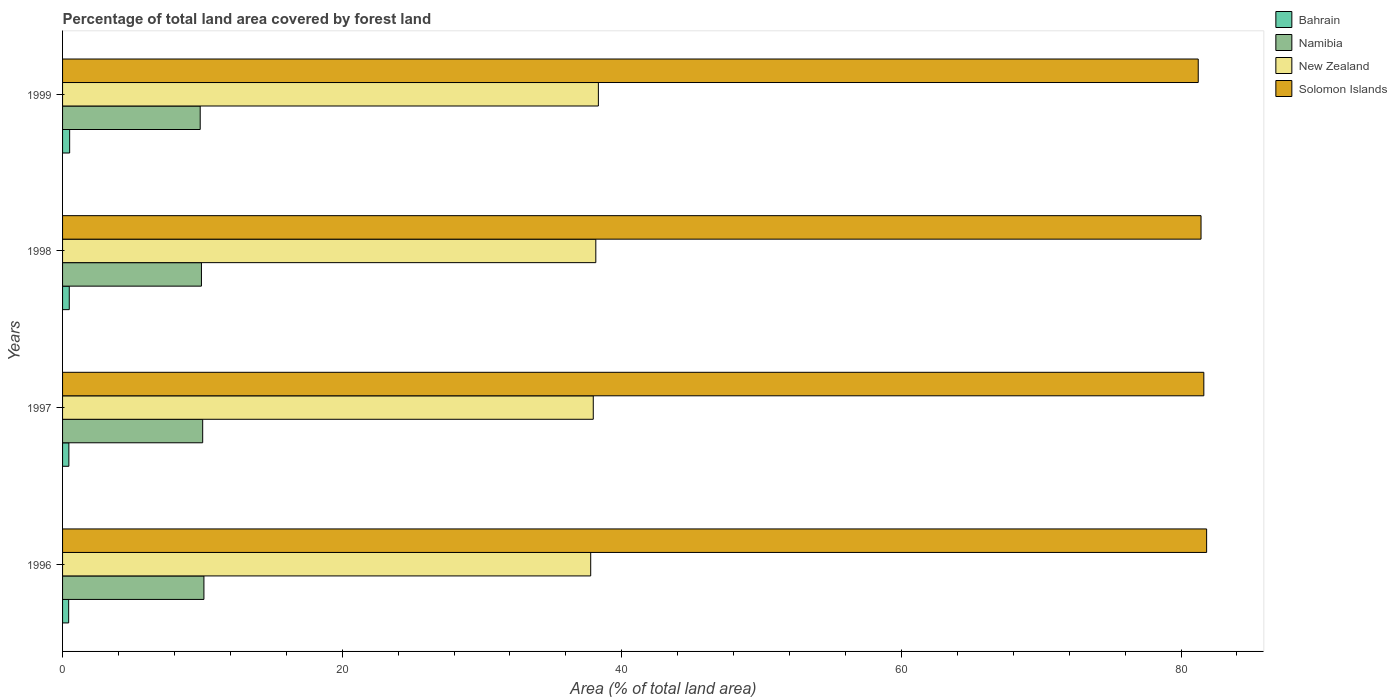How many different coloured bars are there?
Keep it short and to the point. 4. How many groups of bars are there?
Keep it short and to the point. 4. How many bars are there on the 3rd tick from the bottom?
Make the answer very short. 4. What is the label of the 1st group of bars from the top?
Keep it short and to the point. 1999. What is the percentage of forest land in Bahrain in 1997?
Provide a short and direct response. 0.45. Across all years, what is the maximum percentage of forest land in Solomon Islands?
Keep it short and to the point. 81.83. Across all years, what is the minimum percentage of forest land in Bahrain?
Give a very brief answer. 0.44. In which year was the percentage of forest land in Bahrain maximum?
Offer a terse response. 1999. What is the total percentage of forest land in New Zealand in the graph?
Your response must be concise. 152.2. What is the difference between the percentage of forest land in Solomon Islands in 1998 and that in 1999?
Your response must be concise. 0.2. What is the difference between the percentage of forest land in New Zealand in 1997 and the percentage of forest land in Namibia in 1999?
Make the answer very short. 28.11. What is the average percentage of forest land in New Zealand per year?
Make the answer very short. 38.05. In the year 1997, what is the difference between the percentage of forest land in New Zealand and percentage of forest land in Namibia?
Provide a short and direct response. 27.94. In how many years, is the percentage of forest land in Bahrain greater than 4 %?
Ensure brevity in your answer.  0. What is the ratio of the percentage of forest land in Solomon Islands in 1998 to that in 1999?
Make the answer very short. 1. Is the percentage of forest land in Bahrain in 1996 less than that in 1997?
Ensure brevity in your answer.  Yes. Is the difference between the percentage of forest land in New Zealand in 1996 and 1998 greater than the difference between the percentage of forest land in Namibia in 1996 and 1998?
Offer a very short reply. No. What is the difference between the highest and the second highest percentage of forest land in New Zealand?
Your answer should be compact. 0.18. What is the difference between the highest and the lowest percentage of forest land in Bahrain?
Provide a short and direct response. 0.07. Is the sum of the percentage of forest land in Solomon Islands in 1996 and 1997 greater than the maximum percentage of forest land in New Zealand across all years?
Provide a short and direct response. Yes. Is it the case that in every year, the sum of the percentage of forest land in Solomon Islands and percentage of forest land in Namibia is greater than the sum of percentage of forest land in Bahrain and percentage of forest land in New Zealand?
Make the answer very short. Yes. What does the 1st bar from the top in 1997 represents?
Your answer should be very brief. Solomon Islands. What does the 4th bar from the bottom in 1997 represents?
Offer a terse response. Solomon Islands. Is it the case that in every year, the sum of the percentage of forest land in New Zealand and percentage of forest land in Namibia is greater than the percentage of forest land in Bahrain?
Ensure brevity in your answer.  Yes. How many years are there in the graph?
Make the answer very short. 4. How are the legend labels stacked?
Offer a very short reply. Vertical. What is the title of the graph?
Offer a terse response. Percentage of total land area covered by forest land. What is the label or title of the X-axis?
Provide a short and direct response. Area (% of total land area). What is the label or title of the Y-axis?
Your response must be concise. Years. What is the Area (% of total land area) in Bahrain in 1996?
Your answer should be very brief. 0.44. What is the Area (% of total land area) in Namibia in 1996?
Offer a very short reply. 10.11. What is the Area (% of total land area) in New Zealand in 1996?
Provide a succinct answer. 37.78. What is the Area (% of total land area) of Solomon Islands in 1996?
Your answer should be compact. 81.83. What is the Area (% of total land area) of Bahrain in 1997?
Your response must be concise. 0.45. What is the Area (% of total land area) in Namibia in 1997?
Provide a short and direct response. 10.02. What is the Area (% of total land area) of New Zealand in 1997?
Make the answer very short. 37.96. What is the Area (% of total land area) of Solomon Islands in 1997?
Keep it short and to the point. 81.63. What is the Area (% of total land area) in Bahrain in 1998?
Your answer should be compact. 0.48. What is the Area (% of total land area) of Namibia in 1998?
Ensure brevity in your answer.  9.93. What is the Area (% of total land area) in New Zealand in 1998?
Your answer should be compact. 38.14. What is the Area (% of total land area) in Solomon Islands in 1998?
Provide a short and direct response. 81.43. What is the Area (% of total land area) of Bahrain in 1999?
Your answer should be compact. 0.51. What is the Area (% of total land area) in Namibia in 1999?
Your answer should be compact. 9.84. What is the Area (% of total land area) of New Zealand in 1999?
Keep it short and to the point. 38.32. What is the Area (% of total land area) in Solomon Islands in 1999?
Offer a very short reply. 81.23. Across all years, what is the maximum Area (% of total land area) in Bahrain?
Your response must be concise. 0.51. Across all years, what is the maximum Area (% of total land area) of Namibia?
Provide a short and direct response. 10.11. Across all years, what is the maximum Area (% of total land area) of New Zealand?
Provide a short and direct response. 38.32. Across all years, what is the maximum Area (% of total land area) of Solomon Islands?
Make the answer very short. 81.83. Across all years, what is the minimum Area (% of total land area) in Bahrain?
Your answer should be compact. 0.44. Across all years, what is the minimum Area (% of total land area) in Namibia?
Give a very brief answer. 9.84. Across all years, what is the minimum Area (% of total land area) in New Zealand?
Provide a succinct answer. 37.78. Across all years, what is the minimum Area (% of total land area) of Solomon Islands?
Your answer should be very brief. 81.23. What is the total Area (% of total land area) in Bahrain in the graph?
Your answer should be very brief. 1.87. What is the total Area (% of total land area) of Namibia in the graph?
Offer a very short reply. 39.91. What is the total Area (% of total land area) of New Zealand in the graph?
Provide a short and direct response. 152.2. What is the total Area (% of total land area) in Solomon Islands in the graph?
Give a very brief answer. 326.12. What is the difference between the Area (% of total land area) in Bahrain in 1996 and that in 1997?
Provide a short and direct response. -0.01. What is the difference between the Area (% of total land area) of Namibia in 1996 and that in 1997?
Offer a very short reply. 0.09. What is the difference between the Area (% of total land area) in New Zealand in 1996 and that in 1997?
Give a very brief answer. -0.18. What is the difference between the Area (% of total land area) in Solomon Islands in 1996 and that in 1997?
Offer a terse response. 0.2. What is the difference between the Area (% of total land area) of Bahrain in 1996 and that in 1998?
Your answer should be very brief. -0.04. What is the difference between the Area (% of total land area) in Namibia in 1996 and that in 1998?
Offer a very short reply. 0.18. What is the difference between the Area (% of total land area) of New Zealand in 1996 and that in 1998?
Keep it short and to the point. -0.37. What is the difference between the Area (% of total land area) in Solomon Islands in 1996 and that in 1998?
Provide a short and direct response. 0.4. What is the difference between the Area (% of total land area) of Bahrain in 1996 and that in 1999?
Provide a short and direct response. -0.07. What is the difference between the Area (% of total land area) in Namibia in 1996 and that in 1999?
Your answer should be very brief. 0.27. What is the difference between the Area (% of total land area) in New Zealand in 1996 and that in 1999?
Give a very brief answer. -0.55. What is the difference between the Area (% of total land area) in Solomon Islands in 1996 and that in 1999?
Ensure brevity in your answer.  0.6. What is the difference between the Area (% of total land area) of Bahrain in 1997 and that in 1998?
Offer a terse response. -0.03. What is the difference between the Area (% of total land area) in Namibia in 1997 and that in 1998?
Your response must be concise. 0.09. What is the difference between the Area (% of total land area) in New Zealand in 1997 and that in 1998?
Offer a terse response. -0.18. What is the difference between the Area (% of total land area) in Solomon Islands in 1997 and that in 1998?
Ensure brevity in your answer.  0.2. What is the difference between the Area (% of total land area) in Bahrain in 1997 and that in 1999?
Keep it short and to the point. -0.06. What is the difference between the Area (% of total land area) in Namibia in 1997 and that in 1999?
Your response must be concise. 0.18. What is the difference between the Area (% of total land area) in New Zealand in 1997 and that in 1999?
Provide a short and direct response. -0.37. What is the difference between the Area (% of total land area) in Solomon Islands in 1997 and that in 1999?
Offer a very short reply. 0.4. What is the difference between the Area (% of total land area) in Bahrain in 1998 and that in 1999?
Offer a terse response. -0.03. What is the difference between the Area (% of total land area) in Namibia in 1998 and that in 1999?
Your answer should be very brief. 0.09. What is the difference between the Area (% of total land area) of New Zealand in 1998 and that in 1999?
Ensure brevity in your answer.  -0.18. What is the difference between the Area (% of total land area) of Solomon Islands in 1998 and that in 1999?
Provide a short and direct response. 0.2. What is the difference between the Area (% of total land area) of Bahrain in 1996 and the Area (% of total land area) of Namibia in 1997?
Provide a short and direct response. -9.59. What is the difference between the Area (% of total land area) of Bahrain in 1996 and the Area (% of total land area) of New Zealand in 1997?
Keep it short and to the point. -37.52. What is the difference between the Area (% of total land area) of Bahrain in 1996 and the Area (% of total land area) of Solomon Islands in 1997?
Your response must be concise. -81.19. What is the difference between the Area (% of total land area) of Namibia in 1996 and the Area (% of total land area) of New Zealand in 1997?
Your answer should be very brief. -27.85. What is the difference between the Area (% of total land area) in Namibia in 1996 and the Area (% of total land area) in Solomon Islands in 1997?
Offer a terse response. -71.52. What is the difference between the Area (% of total land area) of New Zealand in 1996 and the Area (% of total land area) of Solomon Islands in 1997?
Give a very brief answer. -43.85. What is the difference between the Area (% of total land area) of Bahrain in 1996 and the Area (% of total land area) of Namibia in 1998?
Provide a short and direct response. -9.5. What is the difference between the Area (% of total land area) in Bahrain in 1996 and the Area (% of total land area) in New Zealand in 1998?
Provide a succinct answer. -37.7. What is the difference between the Area (% of total land area) in Bahrain in 1996 and the Area (% of total land area) in Solomon Islands in 1998?
Give a very brief answer. -80.99. What is the difference between the Area (% of total land area) of Namibia in 1996 and the Area (% of total land area) of New Zealand in 1998?
Offer a terse response. -28.03. What is the difference between the Area (% of total land area) in Namibia in 1996 and the Area (% of total land area) in Solomon Islands in 1998?
Give a very brief answer. -71.32. What is the difference between the Area (% of total land area) in New Zealand in 1996 and the Area (% of total land area) in Solomon Islands in 1998?
Provide a succinct answer. -43.65. What is the difference between the Area (% of total land area) in Bahrain in 1996 and the Area (% of total land area) in Namibia in 1999?
Offer a terse response. -9.41. What is the difference between the Area (% of total land area) in Bahrain in 1996 and the Area (% of total land area) in New Zealand in 1999?
Your response must be concise. -37.89. What is the difference between the Area (% of total land area) in Bahrain in 1996 and the Area (% of total land area) in Solomon Islands in 1999?
Your answer should be very brief. -80.79. What is the difference between the Area (% of total land area) of Namibia in 1996 and the Area (% of total land area) of New Zealand in 1999?
Offer a very short reply. -28.21. What is the difference between the Area (% of total land area) in Namibia in 1996 and the Area (% of total land area) in Solomon Islands in 1999?
Make the answer very short. -71.12. What is the difference between the Area (% of total land area) of New Zealand in 1996 and the Area (% of total land area) of Solomon Islands in 1999?
Keep it short and to the point. -43.45. What is the difference between the Area (% of total land area) of Bahrain in 1997 and the Area (% of total land area) of Namibia in 1998?
Provide a succinct answer. -9.48. What is the difference between the Area (% of total land area) in Bahrain in 1997 and the Area (% of total land area) in New Zealand in 1998?
Ensure brevity in your answer.  -37.69. What is the difference between the Area (% of total land area) of Bahrain in 1997 and the Area (% of total land area) of Solomon Islands in 1998?
Provide a short and direct response. -80.98. What is the difference between the Area (% of total land area) in Namibia in 1997 and the Area (% of total land area) in New Zealand in 1998?
Your response must be concise. -28.12. What is the difference between the Area (% of total land area) of Namibia in 1997 and the Area (% of total land area) of Solomon Islands in 1998?
Your answer should be very brief. -71.41. What is the difference between the Area (% of total land area) in New Zealand in 1997 and the Area (% of total land area) in Solomon Islands in 1998?
Keep it short and to the point. -43.47. What is the difference between the Area (% of total land area) in Bahrain in 1997 and the Area (% of total land area) in Namibia in 1999?
Your response must be concise. -9.39. What is the difference between the Area (% of total land area) in Bahrain in 1997 and the Area (% of total land area) in New Zealand in 1999?
Your answer should be compact. -37.87. What is the difference between the Area (% of total land area) of Bahrain in 1997 and the Area (% of total land area) of Solomon Islands in 1999?
Keep it short and to the point. -80.78. What is the difference between the Area (% of total land area) of Namibia in 1997 and the Area (% of total land area) of New Zealand in 1999?
Give a very brief answer. -28.3. What is the difference between the Area (% of total land area) of Namibia in 1997 and the Area (% of total land area) of Solomon Islands in 1999?
Your response must be concise. -71.21. What is the difference between the Area (% of total land area) of New Zealand in 1997 and the Area (% of total land area) of Solomon Islands in 1999?
Your answer should be compact. -43.27. What is the difference between the Area (% of total land area) in Bahrain in 1998 and the Area (% of total land area) in Namibia in 1999?
Ensure brevity in your answer.  -9.37. What is the difference between the Area (% of total land area) in Bahrain in 1998 and the Area (% of total land area) in New Zealand in 1999?
Offer a very short reply. -37.84. What is the difference between the Area (% of total land area) of Bahrain in 1998 and the Area (% of total land area) of Solomon Islands in 1999?
Offer a terse response. -80.75. What is the difference between the Area (% of total land area) of Namibia in 1998 and the Area (% of total land area) of New Zealand in 1999?
Ensure brevity in your answer.  -28.39. What is the difference between the Area (% of total land area) of Namibia in 1998 and the Area (% of total land area) of Solomon Islands in 1999?
Keep it short and to the point. -71.3. What is the difference between the Area (% of total land area) of New Zealand in 1998 and the Area (% of total land area) of Solomon Islands in 1999?
Ensure brevity in your answer.  -43.09. What is the average Area (% of total land area) of Bahrain per year?
Your answer should be very brief. 0.47. What is the average Area (% of total land area) of Namibia per year?
Ensure brevity in your answer.  9.98. What is the average Area (% of total land area) in New Zealand per year?
Keep it short and to the point. 38.05. What is the average Area (% of total land area) of Solomon Islands per year?
Ensure brevity in your answer.  81.53. In the year 1996, what is the difference between the Area (% of total land area) in Bahrain and Area (% of total land area) in Namibia?
Make the answer very short. -9.67. In the year 1996, what is the difference between the Area (% of total land area) in Bahrain and Area (% of total land area) in New Zealand?
Offer a terse response. -37.34. In the year 1996, what is the difference between the Area (% of total land area) in Bahrain and Area (% of total land area) in Solomon Islands?
Provide a short and direct response. -81.39. In the year 1996, what is the difference between the Area (% of total land area) of Namibia and Area (% of total land area) of New Zealand?
Offer a terse response. -27.66. In the year 1996, what is the difference between the Area (% of total land area) in Namibia and Area (% of total land area) in Solomon Islands?
Provide a succinct answer. -71.72. In the year 1996, what is the difference between the Area (% of total land area) of New Zealand and Area (% of total land area) of Solomon Islands?
Your response must be concise. -44.05. In the year 1997, what is the difference between the Area (% of total land area) of Bahrain and Area (% of total land area) of Namibia?
Your answer should be compact. -9.57. In the year 1997, what is the difference between the Area (% of total land area) of Bahrain and Area (% of total land area) of New Zealand?
Keep it short and to the point. -37.51. In the year 1997, what is the difference between the Area (% of total land area) in Bahrain and Area (% of total land area) in Solomon Islands?
Your answer should be compact. -81.18. In the year 1997, what is the difference between the Area (% of total land area) in Namibia and Area (% of total land area) in New Zealand?
Keep it short and to the point. -27.94. In the year 1997, what is the difference between the Area (% of total land area) of Namibia and Area (% of total land area) of Solomon Islands?
Provide a short and direct response. -71.61. In the year 1997, what is the difference between the Area (% of total land area) in New Zealand and Area (% of total land area) in Solomon Islands?
Offer a very short reply. -43.67. In the year 1998, what is the difference between the Area (% of total land area) of Bahrain and Area (% of total land area) of Namibia?
Give a very brief answer. -9.45. In the year 1998, what is the difference between the Area (% of total land area) in Bahrain and Area (% of total land area) in New Zealand?
Provide a succinct answer. -37.66. In the year 1998, what is the difference between the Area (% of total land area) of Bahrain and Area (% of total land area) of Solomon Islands?
Offer a terse response. -80.95. In the year 1998, what is the difference between the Area (% of total land area) in Namibia and Area (% of total land area) in New Zealand?
Your answer should be compact. -28.21. In the year 1998, what is the difference between the Area (% of total land area) in Namibia and Area (% of total land area) in Solomon Islands?
Make the answer very short. -71.5. In the year 1998, what is the difference between the Area (% of total land area) of New Zealand and Area (% of total land area) of Solomon Islands?
Ensure brevity in your answer.  -43.29. In the year 1999, what is the difference between the Area (% of total land area) in Bahrain and Area (% of total land area) in Namibia?
Your answer should be very brief. -9.34. In the year 1999, what is the difference between the Area (% of total land area) of Bahrain and Area (% of total land area) of New Zealand?
Offer a very short reply. -37.82. In the year 1999, what is the difference between the Area (% of total land area) of Bahrain and Area (% of total land area) of Solomon Islands?
Make the answer very short. -80.72. In the year 1999, what is the difference between the Area (% of total land area) in Namibia and Area (% of total land area) in New Zealand?
Make the answer very short. -28.48. In the year 1999, what is the difference between the Area (% of total land area) of Namibia and Area (% of total land area) of Solomon Islands?
Your answer should be very brief. -71.38. In the year 1999, what is the difference between the Area (% of total land area) in New Zealand and Area (% of total land area) in Solomon Islands?
Provide a short and direct response. -42.91. What is the ratio of the Area (% of total land area) in Bahrain in 1996 to that in 1997?
Ensure brevity in your answer.  0.97. What is the ratio of the Area (% of total land area) of Namibia in 1996 to that in 1997?
Make the answer very short. 1.01. What is the ratio of the Area (% of total land area) in New Zealand in 1996 to that in 1997?
Your response must be concise. 1. What is the ratio of the Area (% of total land area) in Solomon Islands in 1996 to that in 1997?
Your response must be concise. 1. What is the ratio of the Area (% of total land area) of Bahrain in 1996 to that in 1998?
Your response must be concise. 0.91. What is the ratio of the Area (% of total land area) in Namibia in 1996 to that in 1998?
Make the answer very short. 1.02. What is the ratio of the Area (% of total land area) of Solomon Islands in 1996 to that in 1998?
Your response must be concise. 1. What is the ratio of the Area (% of total land area) in Bahrain in 1996 to that in 1999?
Make the answer very short. 0.86. What is the ratio of the Area (% of total land area) in New Zealand in 1996 to that in 1999?
Your answer should be very brief. 0.99. What is the ratio of the Area (% of total land area) in Solomon Islands in 1996 to that in 1999?
Offer a terse response. 1.01. What is the ratio of the Area (% of total land area) of Bahrain in 1997 to that in 1998?
Offer a very short reply. 0.94. What is the ratio of the Area (% of total land area) in Namibia in 1997 to that in 1998?
Give a very brief answer. 1.01. What is the ratio of the Area (% of total land area) of Solomon Islands in 1997 to that in 1998?
Your answer should be very brief. 1. What is the ratio of the Area (% of total land area) in New Zealand in 1997 to that in 1999?
Your answer should be compact. 0.99. What is the ratio of the Area (% of total land area) of Solomon Islands in 1998 to that in 1999?
Your response must be concise. 1. What is the difference between the highest and the second highest Area (% of total land area) of Bahrain?
Your response must be concise. 0.03. What is the difference between the highest and the second highest Area (% of total land area) of Namibia?
Provide a short and direct response. 0.09. What is the difference between the highest and the second highest Area (% of total land area) in New Zealand?
Provide a succinct answer. 0.18. What is the difference between the highest and the second highest Area (% of total land area) of Solomon Islands?
Your answer should be compact. 0.2. What is the difference between the highest and the lowest Area (% of total land area) in Bahrain?
Your answer should be compact. 0.07. What is the difference between the highest and the lowest Area (% of total land area) of Namibia?
Offer a terse response. 0.27. What is the difference between the highest and the lowest Area (% of total land area) in New Zealand?
Provide a succinct answer. 0.55. What is the difference between the highest and the lowest Area (% of total land area) in Solomon Islands?
Offer a terse response. 0.6. 